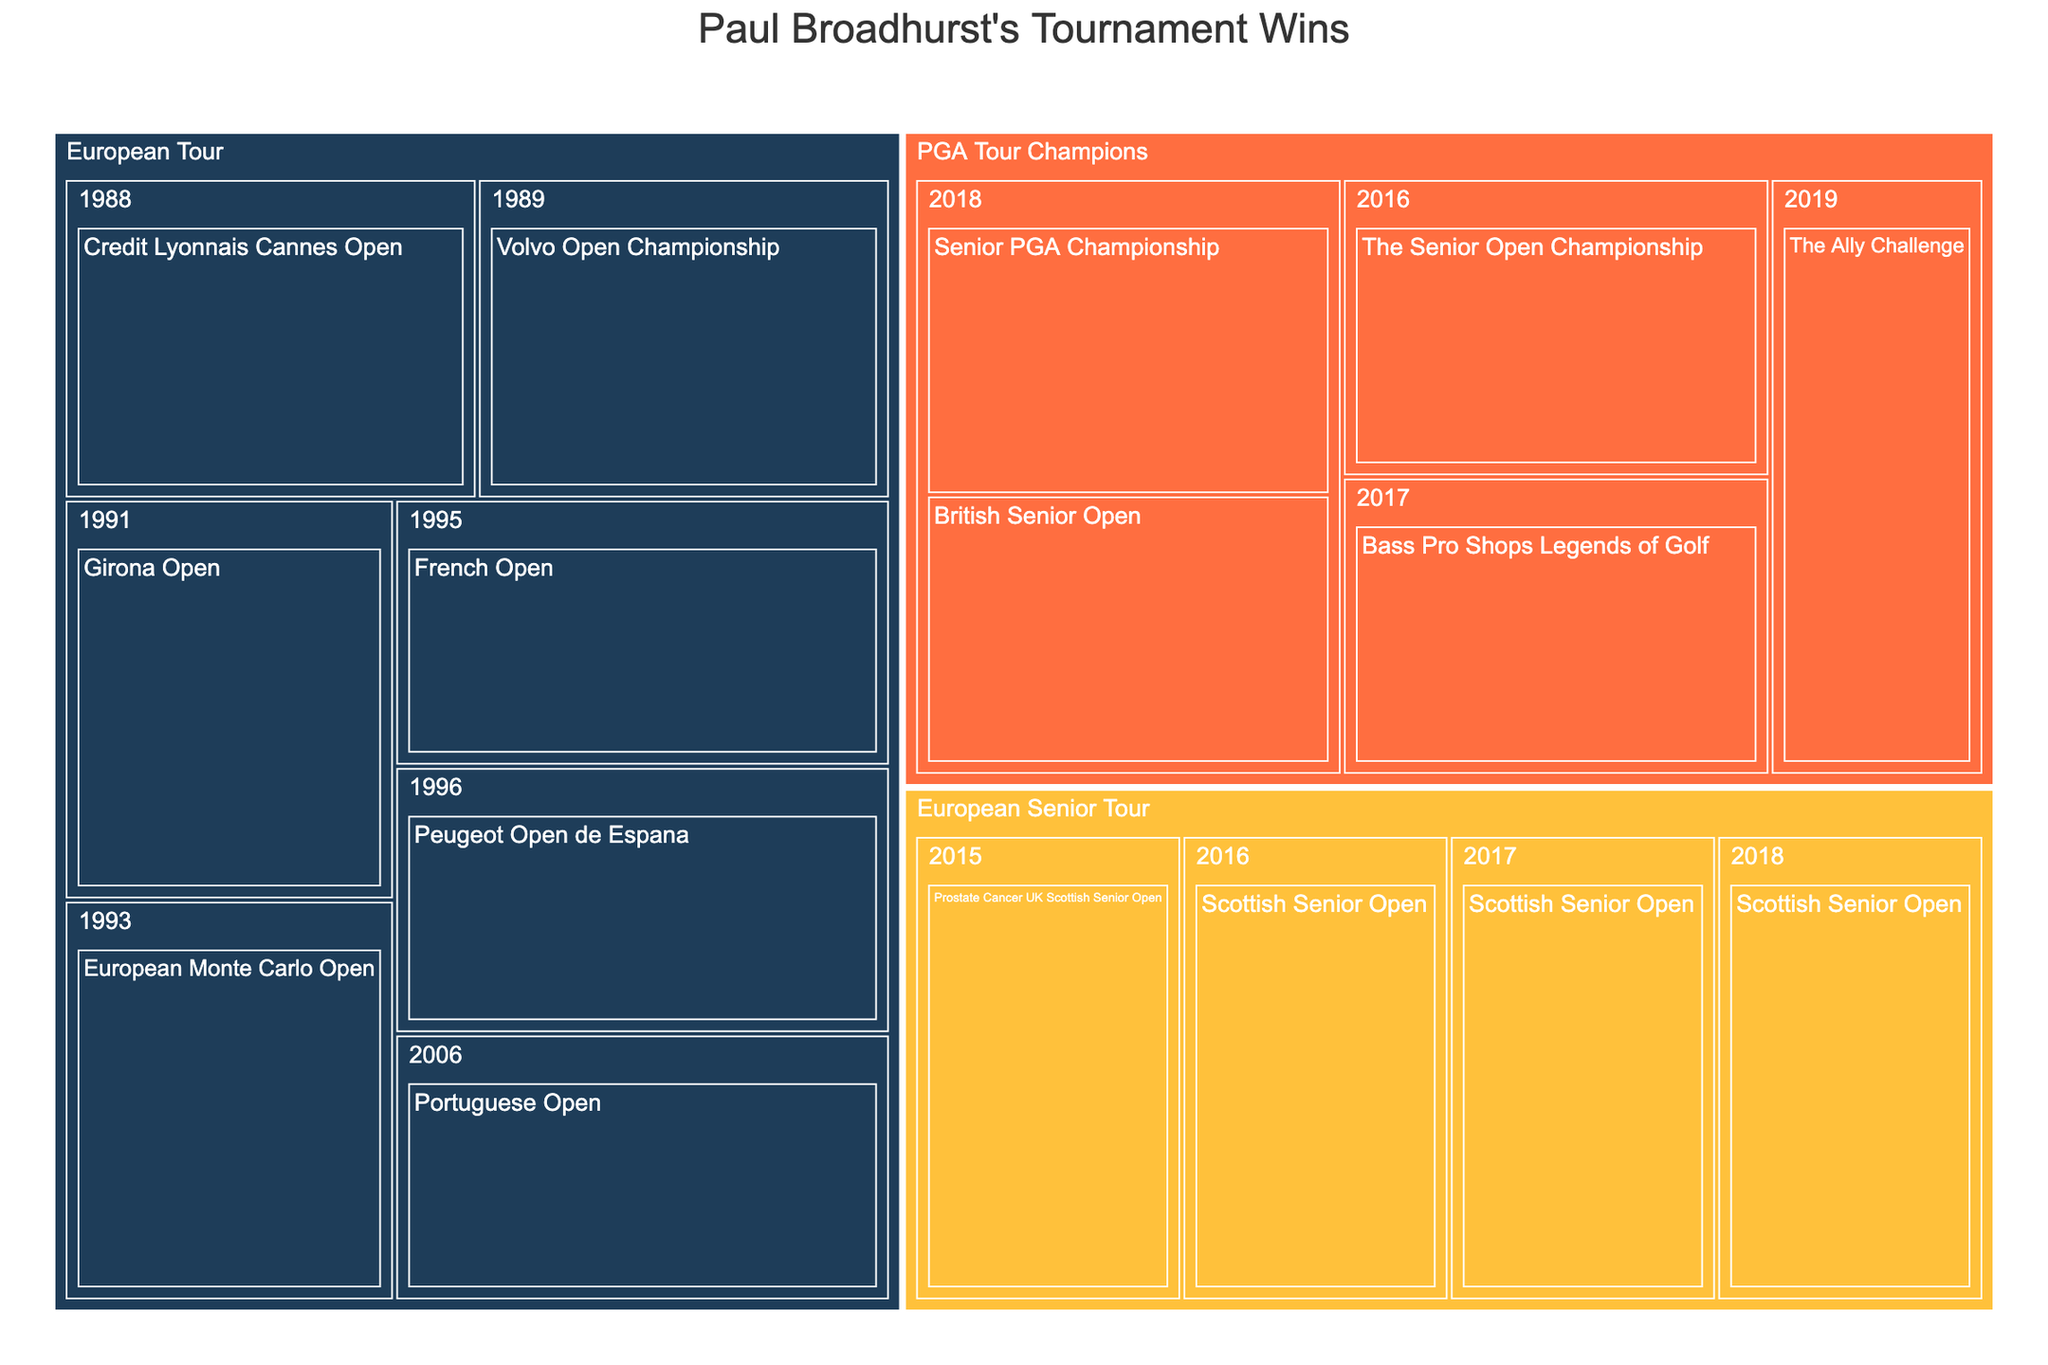What is the title of the treemap? The title is usually placed at the top and is set to provide an overview of what the figure is depicting.
Answer: Paul Broadhurst's Tournament Wins How many tours are represented in the treemap and what are their names? Tours are colored differently and labeled as top-level categories in the treemap. Count the number of top-level categories and note their names.
Answer: Three; European Tour, PGA Tour Champions, European Senior Tour Which tour has the highest number of tournament wins and how many wins does it have? The size of the boxes and the number of elements within them help in determining the tour with the most wins. The European Tour has visibly the largest section with more boxes.
Answer: European Tour with 7 wins In which year did Paul Broadhurst have the most tournament wins and how many? Examine each year within each tour category and count the number of tournaments won in that year.
Answer: 2018 with 3 wins Compare the number of tournament wins in the European Tour and PGA Tour Champions. Which tour has more wins? Count the number of boxes (tournament wins) under each tour category.
Answer: European Tour with 7 wins, compared to PGA Tour Champions with 5 wins List the tournaments won by Paul Broadhurst in 2018. Look under the year 2018 in each tour category to see the individual tournaments listed.
Answer: Senior PGA Championship, British Senior Open, Scottish Senior Open How many times did Paul Broadhurst win the Scottish Senior Open? Identify all boxes labeled "Scottish Senior Open" in the treemap.
Answer: Four times Which tours did Paul Broadhurst win a tournament in 2016 and name the tournaments? Find the year 2016 under the different tour categories and note the tournaments listed.
Answer: European Senior Tour (Scottish Senior Open), PGA Tour Champions (The Senior Open Championship) Identify the first tournament Paul Broadhurst won in his career and the year. Based on the data, locate the earliest year and the corresponding tournament under that year.
Answer: Credit Lyonnais Cannes Open in 1988 Did Paul Broadhurst win any tournaments in consecutive years? If yes, name the tournaments and years. Look for sequences of years under the same tour category and list the tournaments won in those years.
Answer: Yes, Scottish Senior Open in 2016, 2017, and 2018 